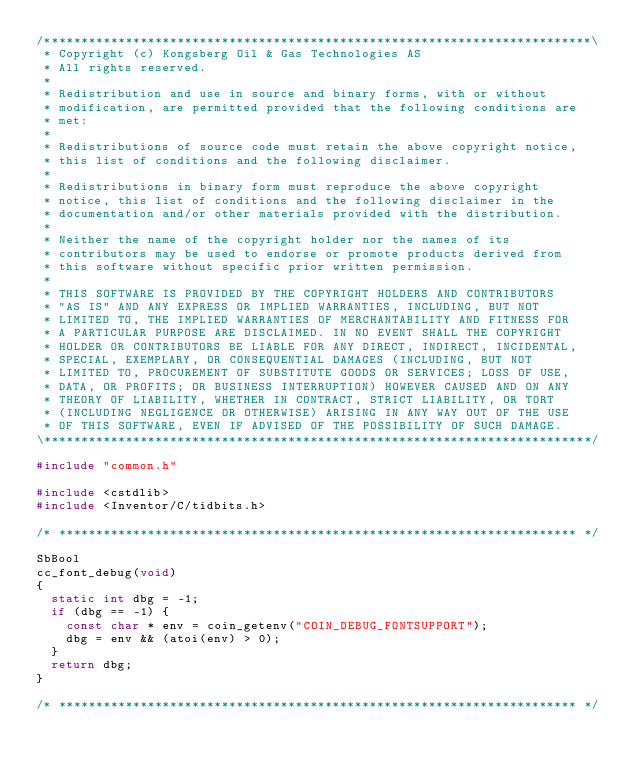Convert code to text. <code><loc_0><loc_0><loc_500><loc_500><_C++_>/**************************************************************************\
 * Copyright (c) Kongsberg Oil & Gas Technologies AS
 * All rights reserved.
 * 
 * Redistribution and use in source and binary forms, with or without
 * modification, are permitted provided that the following conditions are
 * met:
 * 
 * Redistributions of source code must retain the above copyright notice,
 * this list of conditions and the following disclaimer.
 * 
 * Redistributions in binary form must reproduce the above copyright
 * notice, this list of conditions and the following disclaimer in the
 * documentation and/or other materials provided with the distribution.
 * 
 * Neither the name of the copyright holder nor the names of its
 * contributors may be used to endorse or promote products derived from
 * this software without specific prior written permission.
 * 
 * THIS SOFTWARE IS PROVIDED BY THE COPYRIGHT HOLDERS AND CONTRIBUTORS
 * "AS IS" AND ANY EXPRESS OR IMPLIED WARRANTIES, INCLUDING, BUT NOT
 * LIMITED TO, THE IMPLIED WARRANTIES OF MERCHANTABILITY AND FITNESS FOR
 * A PARTICULAR PURPOSE ARE DISCLAIMED. IN NO EVENT SHALL THE COPYRIGHT
 * HOLDER OR CONTRIBUTORS BE LIABLE FOR ANY DIRECT, INDIRECT, INCIDENTAL,
 * SPECIAL, EXEMPLARY, OR CONSEQUENTIAL DAMAGES (INCLUDING, BUT NOT
 * LIMITED TO, PROCUREMENT OF SUBSTITUTE GOODS OR SERVICES; LOSS OF USE,
 * DATA, OR PROFITS; OR BUSINESS INTERRUPTION) HOWEVER CAUSED AND ON ANY
 * THEORY OF LIABILITY, WHETHER IN CONTRACT, STRICT LIABILITY, OR TORT
 * (INCLUDING NEGLIGENCE OR OTHERWISE) ARISING IN ANY WAY OUT OF THE USE
 * OF THIS SOFTWARE, EVEN IF ADVISED OF THE POSSIBILITY OF SUCH DAMAGE.
\**************************************************************************/

#include "common.h"

#include <cstdlib>
#include <Inventor/C/tidbits.h>

/* ********************************************************************** */

SbBool
cc_font_debug(void)
{
  static int dbg = -1;
  if (dbg == -1) {
    const char * env = coin_getenv("COIN_DEBUG_FONTSUPPORT");
    dbg = env && (atoi(env) > 0);
  }
  return dbg;
}

/* ********************************************************************** */
</code> 